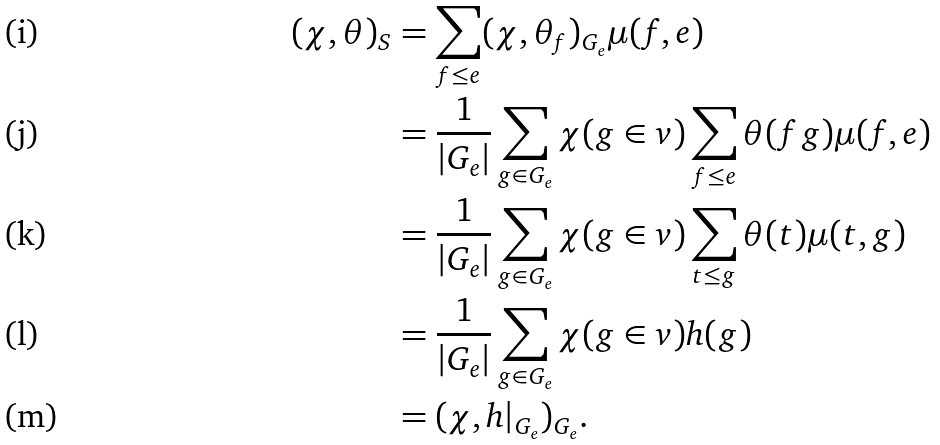Convert formula to latex. <formula><loc_0><loc_0><loc_500><loc_500>( \chi , \theta ) _ { S } & = \sum _ { f \leq e } ( \chi , \theta _ { f } ) _ { G _ { e } } \mu ( f , e ) \\ & = \frac { 1 } { | G _ { e } | } \sum _ { g \in G _ { e } } \chi ( g \in v ) \sum _ { f \leq e } \theta ( f g ) \mu ( f , e ) \\ & = \frac { 1 } { | G _ { e } | } \sum _ { g \in G _ { e } } \chi ( g \in v ) \sum _ { t \leq g } \theta ( t ) \mu ( t , g ) \\ & = \frac { 1 } { | G _ { e } | } \sum _ { g \in G _ { e } } \chi ( g \in v ) h ( g ) \\ & = ( \chi , h | _ { G _ { e } } ) _ { G _ { e } } .</formula> 